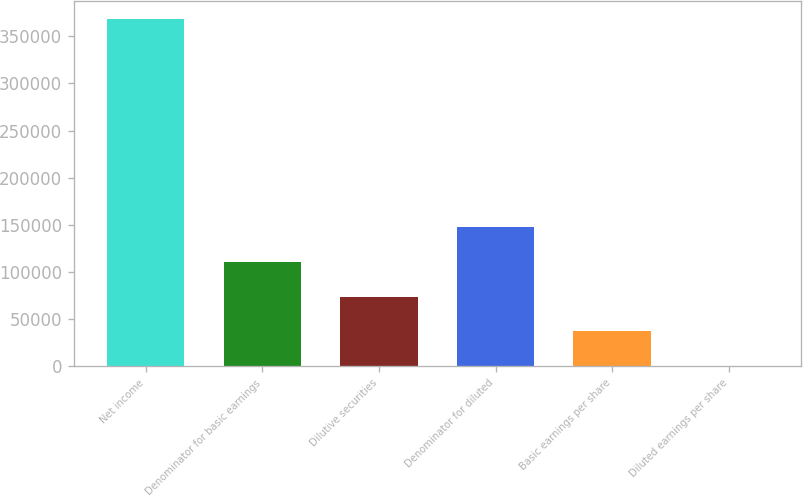Convert chart. <chart><loc_0><loc_0><loc_500><loc_500><bar_chart><fcel>Net income<fcel>Denominator for basic earnings<fcel>Dilutive securities<fcel>Denominator for diluted<fcel>Basic earnings per share<fcel>Diluted earnings per share<nl><fcel>368707<fcel>110615<fcel>73744.8<fcel>147485<fcel>36874.5<fcel>4.24<nl></chart> 